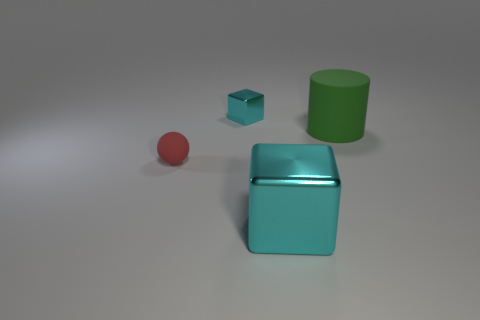There is a cylinder that is the same material as the sphere; what color is it?
Provide a short and direct response. Green. There is a big shiny thing; is it the same color as the small thing behind the green matte cylinder?
Ensure brevity in your answer.  Yes. Is there a metal thing in front of the object right of the cyan metal cube in front of the tiny red thing?
Offer a very short reply. Yes. There is a large object that is the same material as the tiny block; what is its shape?
Your answer should be compact. Cube. Are there any other things that are the same shape as the big cyan metal object?
Your response must be concise. Yes. There is a small cyan thing; what shape is it?
Your response must be concise. Cube. Does the cyan shiny object in front of the small cyan shiny cube have the same shape as the small cyan shiny thing?
Give a very brief answer. Yes. Is the number of things that are behind the small red matte thing greater than the number of red objects that are right of the big cyan object?
Your answer should be very brief. Yes. What number of other things are the same size as the green object?
Your response must be concise. 1. There is a small cyan object; is it the same shape as the big object that is to the left of the green cylinder?
Provide a succinct answer. Yes. 